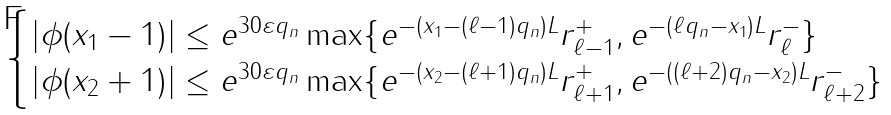<formula> <loc_0><loc_0><loc_500><loc_500>\begin{cases} | \phi ( x _ { 1 } - 1 ) | \leq e ^ { 3 0 \varepsilon q _ { n } } \max \{ e ^ { - ( x _ { 1 } - ( \ell - 1 ) q _ { n } ) L } r _ { \ell - 1 } ^ { + } , e ^ { - ( \ell q _ { n } - x _ { 1 } ) L } r _ { \ell } ^ { - } \} \\ | \phi ( x _ { 2 } + 1 ) | \leq e ^ { 3 0 \varepsilon q _ { n } } \max \{ e ^ { - ( x _ { 2 } - ( \ell + 1 ) q _ { n } ) L } r _ { \ell + 1 } ^ { + } , e ^ { - ( ( \ell + 2 ) q _ { n } - x _ { 2 } ) L } r _ { \ell + 2 } ^ { - } \} \end{cases}</formula> 